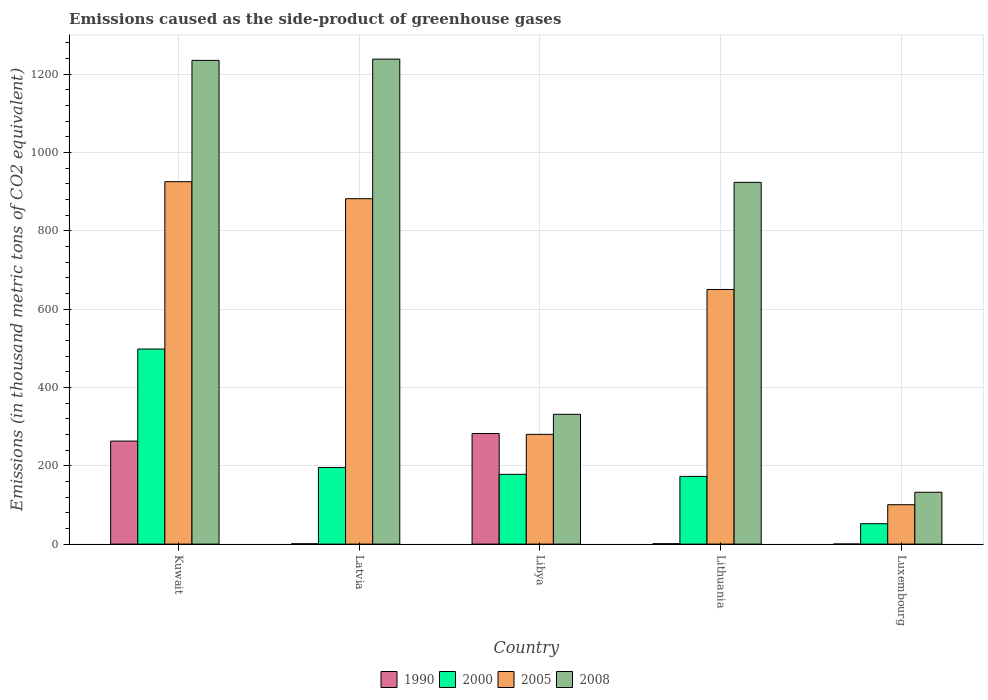How many groups of bars are there?
Give a very brief answer. 5. Are the number of bars on each tick of the X-axis equal?
Keep it short and to the point. Yes. How many bars are there on the 3rd tick from the left?
Keep it short and to the point. 4. What is the label of the 5th group of bars from the left?
Your response must be concise. Luxembourg. What is the emissions caused as the side-product of greenhouse gases in 2005 in Latvia?
Offer a terse response. 882.1. Across all countries, what is the maximum emissions caused as the side-product of greenhouse gases in 2008?
Ensure brevity in your answer.  1238.6. Across all countries, what is the minimum emissions caused as the side-product of greenhouse gases in 2000?
Make the answer very short. 52.1. In which country was the emissions caused as the side-product of greenhouse gases in 2008 maximum?
Ensure brevity in your answer.  Latvia. In which country was the emissions caused as the side-product of greenhouse gases in 1990 minimum?
Ensure brevity in your answer.  Luxembourg. What is the total emissions caused as the side-product of greenhouse gases in 2005 in the graph?
Offer a terse response. 2838.9. What is the difference between the emissions caused as the side-product of greenhouse gases in 2008 in Libya and that in Luxembourg?
Offer a terse response. 199.1. What is the difference between the emissions caused as the side-product of greenhouse gases in 2000 in Lithuania and the emissions caused as the side-product of greenhouse gases in 1990 in Latvia?
Your response must be concise. 172.1. What is the average emissions caused as the side-product of greenhouse gases in 2008 per country?
Provide a succinct answer. 772.36. What is the difference between the emissions caused as the side-product of greenhouse gases of/in 1990 and emissions caused as the side-product of greenhouse gases of/in 2008 in Libya?
Your response must be concise. -49.1. In how many countries, is the emissions caused as the side-product of greenhouse gases in 2000 greater than 720 thousand metric tons?
Provide a short and direct response. 0. What is the ratio of the emissions caused as the side-product of greenhouse gases in 2000 in Libya to that in Luxembourg?
Your answer should be compact. 3.42. What is the difference between the highest and the second highest emissions caused as the side-product of greenhouse gases in 2005?
Keep it short and to the point. -43.5. What is the difference between the highest and the lowest emissions caused as the side-product of greenhouse gases in 2005?
Ensure brevity in your answer.  825. In how many countries, is the emissions caused as the side-product of greenhouse gases in 2000 greater than the average emissions caused as the side-product of greenhouse gases in 2000 taken over all countries?
Provide a short and direct response. 1. Is the sum of the emissions caused as the side-product of greenhouse gases in 2000 in Kuwait and Lithuania greater than the maximum emissions caused as the side-product of greenhouse gases in 2008 across all countries?
Offer a terse response. No. Is it the case that in every country, the sum of the emissions caused as the side-product of greenhouse gases in 1990 and emissions caused as the side-product of greenhouse gases in 2005 is greater than the sum of emissions caused as the side-product of greenhouse gases in 2008 and emissions caused as the side-product of greenhouse gases in 2000?
Your response must be concise. No. Is it the case that in every country, the sum of the emissions caused as the side-product of greenhouse gases in 2000 and emissions caused as the side-product of greenhouse gases in 2008 is greater than the emissions caused as the side-product of greenhouse gases in 1990?
Ensure brevity in your answer.  Yes. How many bars are there?
Your answer should be very brief. 20. What is the difference between two consecutive major ticks on the Y-axis?
Your answer should be compact. 200. Are the values on the major ticks of Y-axis written in scientific E-notation?
Provide a succinct answer. No. Does the graph contain grids?
Ensure brevity in your answer.  Yes. Where does the legend appear in the graph?
Provide a succinct answer. Bottom center. How many legend labels are there?
Keep it short and to the point. 4. How are the legend labels stacked?
Give a very brief answer. Horizontal. What is the title of the graph?
Your response must be concise. Emissions caused as the side-product of greenhouse gases. What is the label or title of the X-axis?
Your answer should be compact. Country. What is the label or title of the Y-axis?
Give a very brief answer. Emissions (in thousand metric tons of CO2 equivalent). What is the Emissions (in thousand metric tons of CO2 equivalent) in 1990 in Kuwait?
Keep it short and to the point. 263.1. What is the Emissions (in thousand metric tons of CO2 equivalent) in 2000 in Kuwait?
Provide a short and direct response. 498.2. What is the Emissions (in thousand metric tons of CO2 equivalent) in 2005 in Kuwait?
Provide a short and direct response. 925.6. What is the Emissions (in thousand metric tons of CO2 equivalent) in 2008 in Kuwait?
Make the answer very short. 1235.4. What is the Emissions (in thousand metric tons of CO2 equivalent) of 1990 in Latvia?
Ensure brevity in your answer.  0.8. What is the Emissions (in thousand metric tons of CO2 equivalent) in 2000 in Latvia?
Your answer should be compact. 195.7. What is the Emissions (in thousand metric tons of CO2 equivalent) of 2005 in Latvia?
Offer a very short reply. 882.1. What is the Emissions (in thousand metric tons of CO2 equivalent) in 2008 in Latvia?
Offer a very short reply. 1238.6. What is the Emissions (in thousand metric tons of CO2 equivalent) in 1990 in Libya?
Keep it short and to the point. 282.4. What is the Emissions (in thousand metric tons of CO2 equivalent) of 2000 in Libya?
Your answer should be compact. 178.2. What is the Emissions (in thousand metric tons of CO2 equivalent) in 2005 in Libya?
Provide a succinct answer. 280.3. What is the Emissions (in thousand metric tons of CO2 equivalent) of 2008 in Libya?
Ensure brevity in your answer.  331.5. What is the Emissions (in thousand metric tons of CO2 equivalent) in 1990 in Lithuania?
Offer a very short reply. 1. What is the Emissions (in thousand metric tons of CO2 equivalent) of 2000 in Lithuania?
Offer a terse response. 172.9. What is the Emissions (in thousand metric tons of CO2 equivalent) of 2005 in Lithuania?
Provide a short and direct response. 650.3. What is the Emissions (in thousand metric tons of CO2 equivalent) in 2008 in Lithuania?
Your answer should be compact. 923.9. What is the Emissions (in thousand metric tons of CO2 equivalent) in 2000 in Luxembourg?
Keep it short and to the point. 52.1. What is the Emissions (in thousand metric tons of CO2 equivalent) in 2005 in Luxembourg?
Keep it short and to the point. 100.6. What is the Emissions (in thousand metric tons of CO2 equivalent) of 2008 in Luxembourg?
Your answer should be very brief. 132.4. Across all countries, what is the maximum Emissions (in thousand metric tons of CO2 equivalent) of 1990?
Offer a terse response. 282.4. Across all countries, what is the maximum Emissions (in thousand metric tons of CO2 equivalent) in 2000?
Offer a terse response. 498.2. Across all countries, what is the maximum Emissions (in thousand metric tons of CO2 equivalent) in 2005?
Give a very brief answer. 925.6. Across all countries, what is the maximum Emissions (in thousand metric tons of CO2 equivalent) of 2008?
Keep it short and to the point. 1238.6. Across all countries, what is the minimum Emissions (in thousand metric tons of CO2 equivalent) of 1990?
Provide a short and direct response. 0.2. Across all countries, what is the minimum Emissions (in thousand metric tons of CO2 equivalent) of 2000?
Provide a succinct answer. 52.1. Across all countries, what is the minimum Emissions (in thousand metric tons of CO2 equivalent) of 2005?
Your answer should be compact. 100.6. Across all countries, what is the minimum Emissions (in thousand metric tons of CO2 equivalent) of 2008?
Your response must be concise. 132.4. What is the total Emissions (in thousand metric tons of CO2 equivalent) in 1990 in the graph?
Your response must be concise. 547.5. What is the total Emissions (in thousand metric tons of CO2 equivalent) of 2000 in the graph?
Provide a short and direct response. 1097.1. What is the total Emissions (in thousand metric tons of CO2 equivalent) in 2005 in the graph?
Offer a terse response. 2838.9. What is the total Emissions (in thousand metric tons of CO2 equivalent) of 2008 in the graph?
Provide a succinct answer. 3861.8. What is the difference between the Emissions (in thousand metric tons of CO2 equivalent) in 1990 in Kuwait and that in Latvia?
Offer a terse response. 262.3. What is the difference between the Emissions (in thousand metric tons of CO2 equivalent) in 2000 in Kuwait and that in Latvia?
Give a very brief answer. 302.5. What is the difference between the Emissions (in thousand metric tons of CO2 equivalent) of 2005 in Kuwait and that in Latvia?
Provide a short and direct response. 43.5. What is the difference between the Emissions (in thousand metric tons of CO2 equivalent) of 1990 in Kuwait and that in Libya?
Your answer should be compact. -19.3. What is the difference between the Emissions (in thousand metric tons of CO2 equivalent) of 2000 in Kuwait and that in Libya?
Provide a short and direct response. 320. What is the difference between the Emissions (in thousand metric tons of CO2 equivalent) in 2005 in Kuwait and that in Libya?
Give a very brief answer. 645.3. What is the difference between the Emissions (in thousand metric tons of CO2 equivalent) of 2008 in Kuwait and that in Libya?
Give a very brief answer. 903.9. What is the difference between the Emissions (in thousand metric tons of CO2 equivalent) of 1990 in Kuwait and that in Lithuania?
Your answer should be compact. 262.1. What is the difference between the Emissions (in thousand metric tons of CO2 equivalent) in 2000 in Kuwait and that in Lithuania?
Give a very brief answer. 325.3. What is the difference between the Emissions (in thousand metric tons of CO2 equivalent) in 2005 in Kuwait and that in Lithuania?
Provide a short and direct response. 275.3. What is the difference between the Emissions (in thousand metric tons of CO2 equivalent) in 2008 in Kuwait and that in Lithuania?
Your answer should be very brief. 311.5. What is the difference between the Emissions (in thousand metric tons of CO2 equivalent) in 1990 in Kuwait and that in Luxembourg?
Your answer should be very brief. 262.9. What is the difference between the Emissions (in thousand metric tons of CO2 equivalent) of 2000 in Kuwait and that in Luxembourg?
Offer a very short reply. 446.1. What is the difference between the Emissions (in thousand metric tons of CO2 equivalent) in 2005 in Kuwait and that in Luxembourg?
Make the answer very short. 825. What is the difference between the Emissions (in thousand metric tons of CO2 equivalent) in 2008 in Kuwait and that in Luxembourg?
Your answer should be compact. 1103. What is the difference between the Emissions (in thousand metric tons of CO2 equivalent) of 1990 in Latvia and that in Libya?
Your answer should be compact. -281.6. What is the difference between the Emissions (in thousand metric tons of CO2 equivalent) in 2005 in Latvia and that in Libya?
Ensure brevity in your answer.  601.8. What is the difference between the Emissions (in thousand metric tons of CO2 equivalent) of 2008 in Latvia and that in Libya?
Ensure brevity in your answer.  907.1. What is the difference between the Emissions (in thousand metric tons of CO2 equivalent) of 2000 in Latvia and that in Lithuania?
Make the answer very short. 22.8. What is the difference between the Emissions (in thousand metric tons of CO2 equivalent) in 2005 in Latvia and that in Lithuania?
Offer a terse response. 231.8. What is the difference between the Emissions (in thousand metric tons of CO2 equivalent) in 2008 in Latvia and that in Lithuania?
Provide a succinct answer. 314.7. What is the difference between the Emissions (in thousand metric tons of CO2 equivalent) of 2000 in Latvia and that in Luxembourg?
Your response must be concise. 143.6. What is the difference between the Emissions (in thousand metric tons of CO2 equivalent) in 2005 in Latvia and that in Luxembourg?
Offer a terse response. 781.5. What is the difference between the Emissions (in thousand metric tons of CO2 equivalent) in 2008 in Latvia and that in Luxembourg?
Offer a very short reply. 1106.2. What is the difference between the Emissions (in thousand metric tons of CO2 equivalent) in 1990 in Libya and that in Lithuania?
Provide a succinct answer. 281.4. What is the difference between the Emissions (in thousand metric tons of CO2 equivalent) of 2000 in Libya and that in Lithuania?
Ensure brevity in your answer.  5.3. What is the difference between the Emissions (in thousand metric tons of CO2 equivalent) of 2005 in Libya and that in Lithuania?
Offer a terse response. -370. What is the difference between the Emissions (in thousand metric tons of CO2 equivalent) of 2008 in Libya and that in Lithuania?
Provide a short and direct response. -592.4. What is the difference between the Emissions (in thousand metric tons of CO2 equivalent) in 1990 in Libya and that in Luxembourg?
Ensure brevity in your answer.  282.2. What is the difference between the Emissions (in thousand metric tons of CO2 equivalent) of 2000 in Libya and that in Luxembourg?
Give a very brief answer. 126.1. What is the difference between the Emissions (in thousand metric tons of CO2 equivalent) of 2005 in Libya and that in Luxembourg?
Provide a short and direct response. 179.7. What is the difference between the Emissions (in thousand metric tons of CO2 equivalent) of 2008 in Libya and that in Luxembourg?
Keep it short and to the point. 199.1. What is the difference between the Emissions (in thousand metric tons of CO2 equivalent) of 2000 in Lithuania and that in Luxembourg?
Your response must be concise. 120.8. What is the difference between the Emissions (in thousand metric tons of CO2 equivalent) in 2005 in Lithuania and that in Luxembourg?
Ensure brevity in your answer.  549.7. What is the difference between the Emissions (in thousand metric tons of CO2 equivalent) of 2008 in Lithuania and that in Luxembourg?
Provide a succinct answer. 791.5. What is the difference between the Emissions (in thousand metric tons of CO2 equivalent) in 1990 in Kuwait and the Emissions (in thousand metric tons of CO2 equivalent) in 2000 in Latvia?
Offer a very short reply. 67.4. What is the difference between the Emissions (in thousand metric tons of CO2 equivalent) in 1990 in Kuwait and the Emissions (in thousand metric tons of CO2 equivalent) in 2005 in Latvia?
Your response must be concise. -619. What is the difference between the Emissions (in thousand metric tons of CO2 equivalent) of 1990 in Kuwait and the Emissions (in thousand metric tons of CO2 equivalent) of 2008 in Latvia?
Your answer should be compact. -975.5. What is the difference between the Emissions (in thousand metric tons of CO2 equivalent) in 2000 in Kuwait and the Emissions (in thousand metric tons of CO2 equivalent) in 2005 in Latvia?
Give a very brief answer. -383.9. What is the difference between the Emissions (in thousand metric tons of CO2 equivalent) in 2000 in Kuwait and the Emissions (in thousand metric tons of CO2 equivalent) in 2008 in Latvia?
Offer a very short reply. -740.4. What is the difference between the Emissions (in thousand metric tons of CO2 equivalent) of 2005 in Kuwait and the Emissions (in thousand metric tons of CO2 equivalent) of 2008 in Latvia?
Ensure brevity in your answer.  -313. What is the difference between the Emissions (in thousand metric tons of CO2 equivalent) of 1990 in Kuwait and the Emissions (in thousand metric tons of CO2 equivalent) of 2000 in Libya?
Your answer should be very brief. 84.9. What is the difference between the Emissions (in thousand metric tons of CO2 equivalent) in 1990 in Kuwait and the Emissions (in thousand metric tons of CO2 equivalent) in 2005 in Libya?
Your answer should be very brief. -17.2. What is the difference between the Emissions (in thousand metric tons of CO2 equivalent) in 1990 in Kuwait and the Emissions (in thousand metric tons of CO2 equivalent) in 2008 in Libya?
Give a very brief answer. -68.4. What is the difference between the Emissions (in thousand metric tons of CO2 equivalent) in 2000 in Kuwait and the Emissions (in thousand metric tons of CO2 equivalent) in 2005 in Libya?
Offer a very short reply. 217.9. What is the difference between the Emissions (in thousand metric tons of CO2 equivalent) in 2000 in Kuwait and the Emissions (in thousand metric tons of CO2 equivalent) in 2008 in Libya?
Make the answer very short. 166.7. What is the difference between the Emissions (in thousand metric tons of CO2 equivalent) in 2005 in Kuwait and the Emissions (in thousand metric tons of CO2 equivalent) in 2008 in Libya?
Your answer should be very brief. 594.1. What is the difference between the Emissions (in thousand metric tons of CO2 equivalent) in 1990 in Kuwait and the Emissions (in thousand metric tons of CO2 equivalent) in 2000 in Lithuania?
Your response must be concise. 90.2. What is the difference between the Emissions (in thousand metric tons of CO2 equivalent) in 1990 in Kuwait and the Emissions (in thousand metric tons of CO2 equivalent) in 2005 in Lithuania?
Your response must be concise. -387.2. What is the difference between the Emissions (in thousand metric tons of CO2 equivalent) in 1990 in Kuwait and the Emissions (in thousand metric tons of CO2 equivalent) in 2008 in Lithuania?
Keep it short and to the point. -660.8. What is the difference between the Emissions (in thousand metric tons of CO2 equivalent) of 2000 in Kuwait and the Emissions (in thousand metric tons of CO2 equivalent) of 2005 in Lithuania?
Your answer should be very brief. -152.1. What is the difference between the Emissions (in thousand metric tons of CO2 equivalent) in 2000 in Kuwait and the Emissions (in thousand metric tons of CO2 equivalent) in 2008 in Lithuania?
Your response must be concise. -425.7. What is the difference between the Emissions (in thousand metric tons of CO2 equivalent) in 2005 in Kuwait and the Emissions (in thousand metric tons of CO2 equivalent) in 2008 in Lithuania?
Give a very brief answer. 1.7. What is the difference between the Emissions (in thousand metric tons of CO2 equivalent) of 1990 in Kuwait and the Emissions (in thousand metric tons of CO2 equivalent) of 2000 in Luxembourg?
Keep it short and to the point. 211. What is the difference between the Emissions (in thousand metric tons of CO2 equivalent) in 1990 in Kuwait and the Emissions (in thousand metric tons of CO2 equivalent) in 2005 in Luxembourg?
Your response must be concise. 162.5. What is the difference between the Emissions (in thousand metric tons of CO2 equivalent) in 1990 in Kuwait and the Emissions (in thousand metric tons of CO2 equivalent) in 2008 in Luxembourg?
Your answer should be very brief. 130.7. What is the difference between the Emissions (in thousand metric tons of CO2 equivalent) in 2000 in Kuwait and the Emissions (in thousand metric tons of CO2 equivalent) in 2005 in Luxembourg?
Keep it short and to the point. 397.6. What is the difference between the Emissions (in thousand metric tons of CO2 equivalent) of 2000 in Kuwait and the Emissions (in thousand metric tons of CO2 equivalent) of 2008 in Luxembourg?
Provide a short and direct response. 365.8. What is the difference between the Emissions (in thousand metric tons of CO2 equivalent) of 2005 in Kuwait and the Emissions (in thousand metric tons of CO2 equivalent) of 2008 in Luxembourg?
Make the answer very short. 793.2. What is the difference between the Emissions (in thousand metric tons of CO2 equivalent) in 1990 in Latvia and the Emissions (in thousand metric tons of CO2 equivalent) in 2000 in Libya?
Give a very brief answer. -177.4. What is the difference between the Emissions (in thousand metric tons of CO2 equivalent) in 1990 in Latvia and the Emissions (in thousand metric tons of CO2 equivalent) in 2005 in Libya?
Your response must be concise. -279.5. What is the difference between the Emissions (in thousand metric tons of CO2 equivalent) in 1990 in Latvia and the Emissions (in thousand metric tons of CO2 equivalent) in 2008 in Libya?
Give a very brief answer. -330.7. What is the difference between the Emissions (in thousand metric tons of CO2 equivalent) of 2000 in Latvia and the Emissions (in thousand metric tons of CO2 equivalent) of 2005 in Libya?
Offer a terse response. -84.6. What is the difference between the Emissions (in thousand metric tons of CO2 equivalent) in 2000 in Latvia and the Emissions (in thousand metric tons of CO2 equivalent) in 2008 in Libya?
Make the answer very short. -135.8. What is the difference between the Emissions (in thousand metric tons of CO2 equivalent) of 2005 in Latvia and the Emissions (in thousand metric tons of CO2 equivalent) of 2008 in Libya?
Your answer should be compact. 550.6. What is the difference between the Emissions (in thousand metric tons of CO2 equivalent) of 1990 in Latvia and the Emissions (in thousand metric tons of CO2 equivalent) of 2000 in Lithuania?
Offer a very short reply. -172.1. What is the difference between the Emissions (in thousand metric tons of CO2 equivalent) of 1990 in Latvia and the Emissions (in thousand metric tons of CO2 equivalent) of 2005 in Lithuania?
Offer a very short reply. -649.5. What is the difference between the Emissions (in thousand metric tons of CO2 equivalent) of 1990 in Latvia and the Emissions (in thousand metric tons of CO2 equivalent) of 2008 in Lithuania?
Your answer should be compact. -923.1. What is the difference between the Emissions (in thousand metric tons of CO2 equivalent) in 2000 in Latvia and the Emissions (in thousand metric tons of CO2 equivalent) in 2005 in Lithuania?
Make the answer very short. -454.6. What is the difference between the Emissions (in thousand metric tons of CO2 equivalent) of 2000 in Latvia and the Emissions (in thousand metric tons of CO2 equivalent) of 2008 in Lithuania?
Provide a short and direct response. -728.2. What is the difference between the Emissions (in thousand metric tons of CO2 equivalent) of 2005 in Latvia and the Emissions (in thousand metric tons of CO2 equivalent) of 2008 in Lithuania?
Offer a very short reply. -41.8. What is the difference between the Emissions (in thousand metric tons of CO2 equivalent) of 1990 in Latvia and the Emissions (in thousand metric tons of CO2 equivalent) of 2000 in Luxembourg?
Offer a very short reply. -51.3. What is the difference between the Emissions (in thousand metric tons of CO2 equivalent) of 1990 in Latvia and the Emissions (in thousand metric tons of CO2 equivalent) of 2005 in Luxembourg?
Provide a succinct answer. -99.8. What is the difference between the Emissions (in thousand metric tons of CO2 equivalent) in 1990 in Latvia and the Emissions (in thousand metric tons of CO2 equivalent) in 2008 in Luxembourg?
Keep it short and to the point. -131.6. What is the difference between the Emissions (in thousand metric tons of CO2 equivalent) in 2000 in Latvia and the Emissions (in thousand metric tons of CO2 equivalent) in 2005 in Luxembourg?
Provide a succinct answer. 95.1. What is the difference between the Emissions (in thousand metric tons of CO2 equivalent) of 2000 in Latvia and the Emissions (in thousand metric tons of CO2 equivalent) of 2008 in Luxembourg?
Provide a succinct answer. 63.3. What is the difference between the Emissions (in thousand metric tons of CO2 equivalent) of 2005 in Latvia and the Emissions (in thousand metric tons of CO2 equivalent) of 2008 in Luxembourg?
Provide a short and direct response. 749.7. What is the difference between the Emissions (in thousand metric tons of CO2 equivalent) in 1990 in Libya and the Emissions (in thousand metric tons of CO2 equivalent) in 2000 in Lithuania?
Offer a very short reply. 109.5. What is the difference between the Emissions (in thousand metric tons of CO2 equivalent) of 1990 in Libya and the Emissions (in thousand metric tons of CO2 equivalent) of 2005 in Lithuania?
Offer a terse response. -367.9. What is the difference between the Emissions (in thousand metric tons of CO2 equivalent) of 1990 in Libya and the Emissions (in thousand metric tons of CO2 equivalent) of 2008 in Lithuania?
Your answer should be very brief. -641.5. What is the difference between the Emissions (in thousand metric tons of CO2 equivalent) of 2000 in Libya and the Emissions (in thousand metric tons of CO2 equivalent) of 2005 in Lithuania?
Offer a terse response. -472.1. What is the difference between the Emissions (in thousand metric tons of CO2 equivalent) of 2000 in Libya and the Emissions (in thousand metric tons of CO2 equivalent) of 2008 in Lithuania?
Your answer should be very brief. -745.7. What is the difference between the Emissions (in thousand metric tons of CO2 equivalent) of 2005 in Libya and the Emissions (in thousand metric tons of CO2 equivalent) of 2008 in Lithuania?
Provide a short and direct response. -643.6. What is the difference between the Emissions (in thousand metric tons of CO2 equivalent) in 1990 in Libya and the Emissions (in thousand metric tons of CO2 equivalent) in 2000 in Luxembourg?
Your answer should be compact. 230.3. What is the difference between the Emissions (in thousand metric tons of CO2 equivalent) of 1990 in Libya and the Emissions (in thousand metric tons of CO2 equivalent) of 2005 in Luxembourg?
Give a very brief answer. 181.8. What is the difference between the Emissions (in thousand metric tons of CO2 equivalent) in 1990 in Libya and the Emissions (in thousand metric tons of CO2 equivalent) in 2008 in Luxembourg?
Your answer should be compact. 150. What is the difference between the Emissions (in thousand metric tons of CO2 equivalent) of 2000 in Libya and the Emissions (in thousand metric tons of CO2 equivalent) of 2005 in Luxembourg?
Offer a very short reply. 77.6. What is the difference between the Emissions (in thousand metric tons of CO2 equivalent) of 2000 in Libya and the Emissions (in thousand metric tons of CO2 equivalent) of 2008 in Luxembourg?
Your response must be concise. 45.8. What is the difference between the Emissions (in thousand metric tons of CO2 equivalent) in 2005 in Libya and the Emissions (in thousand metric tons of CO2 equivalent) in 2008 in Luxembourg?
Your answer should be compact. 147.9. What is the difference between the Emissions (in thousand metric tons of CO2 equivalent) of 1990 in Lithuania and the Emissions (in thousand metric tons of CO2 equivalent) of 2000 in Luxembourg?
Ensure brevity in your answer.  -51.1. What is the difference between the Emissions (in thousand metric tons of CO2 equivalent) in 1990 in Lithuania and the Emissions (in thousand metric tons of CO2 equivalent) in 2005 in Luxembourg?
Your response must be concise. -99.6. What is the difference between the Emissions (in thousand metric tons of CO2 equivalent) in 1990 in Lithuania and the Emissions (in thousand metric tons of CO2 equivalent) in 2008 in Luxembourg?
Keep it short and to the point. -131.4. What is the difference between the Emissions (in thousand metric tons of CO2 equivalent) in 2000 in Lithuania and the Emissions (in thousand metric tons of CO2 equivalent) in 2005 in Luxembourg?
Offer a very short reply. 72.3. What is the difference between the Emissions (in thousand metric tons of CO2 equivalent) of 2000 in Lithuania and the Emissions (in thousand metric tons of CO2 equivalent) of 2008 in Luxembourg?
Offer a terse response. 40.5. What is the difference between the Emissions (in thousand metric tons of CO2 equivalent) in 2005 in Lithuania and the Emissions (in thousand metric tons of CO2 equivalent) in 2008 in Luxembourg?
Give a very brief answer. 517.9. What is the average Emissions (in thousand metric tons of CO2 equivalent) in 1990 per country?
Give a very brief answer. 109.5. What is the average Emissions (in thousand metric tons of CO2 equivalent) in 2000 per country?
Your answer should be very brief. 219.42. What is the average Emissions (in thousand metric tons of CO2 equivalent) of 2005 per country?
Ensure brevity in your answer.  567.78. What is the average Emissions (in thousand metric tons of CO2 equivalent) in 2008 per country?
Give a very brief answer. 772.36. What is the difference between the Emissions (in thousand metric tons of CO2 equivalent) of 1990 and Emissions (in thousand metric tons of CO2 equivalent) of 2000 in Kuwait?
Offer a terse response. -235.1. What is the difference between the Emissions (in thousand metric tons of CO2 equivalent) in 1990 and Emissions (in thousand metric tons of CO2 equivalent) in 2005 in Kuwait?
Offer a very short reply. -662.5. What is the difference between the Emissions (in thousand metric tons of CO2 equivalent) of 1990 and Emissions (in thousand metric tons of CO2 equivalent) of 2008 in Kuwait?
Ensure brevity in your answer.  -972.3. What is the difference between the Emissions (in thousand metric tons of CO2 equivalent) of 2000 and Emissions (in thousand metric tons of CO2 equivalent) of 2005 in Kuwait?
Your answer should be very brief. -427.4. What is the difference between the Emissions (in thousand metric tons of CO2 equivalent) in 2000 and Emissions (in thousand metric tons of CO2 equivalent) in 2008 in Kuwait?
Give a very brief answer. -737.2. What is the difference between the Emissions (in thousand metric tons of CO2 equivalent) in 2005 and Emissions (in thousand metric tons of CO2 equivalent) in 2008 in Kuwait?
Offer a terse response. -309.8. What is the difference between the Emissions (in thousand metric tons of CO2 equivalent) in 1990 and Emissions (in thousand metric tons of CO2 equivalent) in 2000 in Latvia?
Provide a succinct answer. -194.9. What is the difference between the Emissions (in thousand metric tons of CO2 equivalent) in 1990 and Emissions (in thousand metric tons of CO2 equivalent) in 2005 in Latvia?
Give a very brief answer. -881.3. What is the difference between the Emissions (in thousand metric tons of CO2 equivalent) in 1990 and Emissions (in thousand metric tons of CO2 equivalent) in 2008 in Latvia?
Keep it short and to the point. -1237.8. What is the difference between the Emissions (in thousand metric tons of CO2 equivalent) of 2000 and Emissions (in thousand metric tons of CO2 equivalent) of 2005 in Latvia?
Keep it short and to the point. -686.4. What is the difference between the Emissions (in thousand metric tons of CO2 equivalent) in 2000 and Emissions (in thousand metric tons of CO2 equivalent) in 2008 in Latvia?
Offer a terse response. -1042.9. What is the difference between the Emissions (in thousand metric tons of CO2 equivalent) in 2005 and Emissions (in thousand metric tons of CO2 equivalent) in 2008 in Latvia?
Offer a terse response. -356.5. What is the difference between the Emissions (in thousand metric tons of CO2 equivalent) of 1990 and Emissions (in thousand metric tons of CO2 equivalent) of 2000 in Libya?
Provide a short and direct response. 104.2. What is the difference between the Emissions (in thousand metric tons of CO2 equivalent) in 1990 and Emissions (in thousand metric tons of CO2 equivalent) in 2005 in Libya?
Offer a very short reply. 2.1. What is the difference between the Emissions (in thousand metric tons of CO2 equivalent) in 1990 and Emissions (in thousand metric tons of CO2 equivalent) in 2008 in Libya?
Offer a terse response. -49.1. What is the difference between the Emissions (in thousand metric tons of CO2 equivalent) in 2000 and Emissions (in thousand metric tons of CO2 equivalent) in 2005 in Libya?
Your response must be concise. -102.1. What is the difference between the Emissions (in thousand metric tons of CO2 equivalent) of 2000 and Emissions (in thousand metric tons of CO2 equivalent) of 2008 in Libya?
Offer a terse response. -153.3. What is the difference between the Emissions (in thousand metric tons of CO2 equivalent) in 2005 and Emissions (in thousand metric tons of CO2 equivalent) in 2008 in Libya?
Provide a short and direct response. -51.2. What is the difference between the Emissions (in thousand metric tons of CO2 equivalent) of 1990 and Emissions (in thousand metric tons of CO2 equivalent) of 2000 in Lithuania?
Provide a short and direct response. -171.9. What is the difference between the Emissions (in thousand metric tons of CO2 equivalent) in 1990 and Emissions (in thousand metric tons of CO2 equivalent) in 2005 in Lithuania?
Offer a terse response. -649.3. What is the difference between the Emissions (in thousand metric tons of CO2 equivalent) in 1990 and Emissions (in thousand metric tons of CO2 equivalent) in 2008 in Lithuania?
Ensure brevity in your answer.  -922.9. What is the difference between the Emissions (in thousand metric tons of CO2 equivalent) in 2000 and Emissions (in thousand metric tons of CO2 equivalent) in 2005 in Lithuania?
Offer a very short reply. -477.4. What is the difference between the Emissions (in thousand metric tons of CO2 equivalent) in 2000 and Emissions (in thousand metric tons of CO2 equivalent) in 2008 in Lithuania?
Provide a succinct answer. -751. What is the difference between the Emissions (in thousand metric tons of CO2 equivalent) of 2005 and Emissions (in thousand metric tons of CO2 equivalent) of 2008 in Lithuania?
Provide a succinct answer. -273.6. What is the difference between the Emissions (in thousand metric tons of CO2 equivalent) in 1990 and Emissions (in thousand metric tons of CO2 equivalent) in 2000 in Luxembourg?
Make the answer very short. -51.9. What is the difference between the Emissions (in thousand metric tons of CO2 equivalent) in 1990 and Emissions (in thousand metric tons of CO2 equivalent) in 2005 in Luxembourg?
Your response must be concise. -100.4. What is the difference between the Emissions (in thousand metric tons of CO2 equivalent) in 1990 and Emissions (in thousand metric tons of CO2 equivalent) in 2008 in Luxembourg?
Offer a very short reply. -132.2. What is the difference between the Emissions (in thousand metric tons of CO2 equivalent) in 2000 and Emissions (in thousand metric tons of CO2 equivalent) in 2005 in Luxembourg?
Keep it short and to the point. -48.5. What is the difference between the Emissions (in thousand metric tons of CO2 equivalent) in 2000 and Emissions (in thousand metric tons of CO2 equivalent) in 2008 in Luxembourg?
Give a very brief answer. -80.3. What is the difference between the Emissions (in thousand metric tons of CO2 equivalent) in 2005 and Emissions (in thousand metric tons of CO2 equivalent) in 2008 in Luxembourg?
Offer a very short reply. -31.8. What is the ratio of the Emissions (in thousand metric tons of CO2 equivalent) in 1990 in Kuwait to that in Latvia?
Your response must be concise. 328.88. What is the ratio of the Emissions (in thousand metric tons of CO2 equivalent) of 2000 in Kuwait to that in Latvia?
Your response must be concise. 2.55. What is the ratio of the Emissions (in thousand metric tons of CO2 equivalent) in 2005 in Kuwait to that in Latvia?
Provide a succinct answer. 1.05. What is the ratio of the Emissions (in thousand metric tons of CO2 equivalent) of 1990 in Kuwait to that in Libya?
Ensure brevity in your answer.  0.93. What is the ratio of the Emissions (in thousand metric tons of CO2 equivalent) in 2000 in Kuwait to that in Libya?
Offer a terse response. 2.8. What is the ratio of the Emissions (in thousand metric tons of CO2 equivalent) of 2005 in Kuwait to that in Libya?
Offer a terse response. 3.3. What is the ratio of the Emissions (in thousand metric tons of CO2 equivalent) in 2008 in Kuwait to that in Libya?
Ensure brevity in your answer.  3.73. What is the ratio of the Emissions (in thousand metric tons of CO2 equivalent) in 1990 in Kuwait to that in Lithuania?
Keep it short and to the point. 263.1. What is the ratio of the Emissions (in thousand metric tons of CO2 equivalent) of 2000 in Kuwait to that in Lithuania?
Your response must be concise. 2.88. What is the ratio of the Emissions (in thousand metric tons of CO2 equivalent) in 2005 in Kuwait to that in Lithuania?
Provide a short and direct response. 1.42. What is the ratio of the Emissions (in thousand metric tons of CO2 equivalent) in 2008 in Kuwait to that in Lithuania?
Your answer should be compact. 1.34. What is the ratio of the Emissions (in thousand metric tons of CO2 equivalent) in 1990 in Kuwait to that in Luxembourg?
Ensure brevity in your answer.  1315.5. What is the ratio of the Emissions (in thousand metric tons of CO2 equivalent) in 2000 in Kuwait to that in Luxembourg?
Keep it short and to the point. 9.56. What is the ratio of the Emissions (in thousand metric tons of CO2 equivalent) in 2005 in Kuwait to that in Luxembourg?
Give a very brief answer. 9.2. What is the ratio of the Emissions (in thousand metric tons of CO2 equivalent) in 2008 in Kuwait to that in Luxembourg?
Provide a short and direct response. 9.33. What is the ratio of the Emissions (in thousand metric tons of CO2 equivalent) of 1990 in Latvia to that in Libya?
Your answer should be very brief. 0. What is the ratio of the Emissions (in thousand metric tons of CO2 equivalent) of 2000 in Latvia to that in Libya?
Give a very brief answer. 1.1. What is the ratio of the Emissions (in thousand metric tons of CO2 equivalent) of 2005 in Latvia to that in Libya?
Your answer should be very brief. 3.15. What is the ratio of the Emissions (in thousand metric tons of CO2 equivalent) in 2008 in Latvia to that in Libya?
Ensure brevity in your answer.  3.74. What is the ratio of the Emissions (in thousand metric tons of CO2 equivalent) in 2000 in Latvia to that in Lithuania?
Offer a very short reply. 1.13. What is the ratio of the Emissions (in thousand metric tons of CO2 equivalent) in 2005 in Latvia to that in Lithuania?
Your answer should be very brief. 1.36. What is the ratio of the Emissions (in thousand metric tons of CO2 equivalent) of 2008 in Latvia to that in Lithuania?
Offer a terse response. 1.34. What is the ratio of the Emissions (in thousand metric tons of CO2 equivalent) in 2000 in Latvia to that in Luxembourg?
Offer a terse response. 3.76. What is the ratio of the Emissions (in thousand metric tons of CO2 equivalent) in 2005 in Latvia to that in Luxembourg?
Keep it short and to the point. 8.77. What is the ratio of the Emissions (in thousand metric tons of CO2 equivalent) in 2008 in Latvia to that in Luxembourg?
Offer a terse response. 9.36. What is the ratio of the Emissions (in thousand metric tons of CO2 equivalent) of 1990 in Libya to that in Lithuania?
Offer a terse response. 282.4. What is the ratio of the Emissions (in thousand metric tons of CO2 equivalent) in 2000 in Libya to that in Lithuania?
Provide a short and direct response. 1.03. What is the ratio of the Emissions (in thousand metric tons of CO2 equivalent) of 2005 in Libya to that in Lithuania?
Make the answer very short. 0.43. What is the ratio of the Emissions (in thousand metric tons of CO2 equivalent) in 2008 in Libya to that in Lithuania?
Your response must be concise. 0.36. What is the ratio of the Emissions (in thousand metric tons of CO2 equivalent) of 1990 in Libya to that in Luxembourg?
Your answer should be very brief. 1412. What is the ratio of the Emissions (in thousand metric tons of CO2 equivalent) of 2000 in Libya to that in Luxembourg?
Keep it short and to the point. 3.42. What is the ratio of the Emissions (in thousand metric tons of CO2 equivalent) of 2005 in Libya to that in Luxembourg?
Make the answer very short. 2.79. What is the ratio of the Emissions (in thousand metric tons of CO2 equivalent) of 2008 in Libya to that in Luxembourg?
Keep it short and to the point. 2.5. What is the ratio of the Emissions (in thousand metric tons of CO2 equivalent) in 2000 in Lithuania to that in Luxembourg?
Your answer should be very brief. 3.32. What is the ratio of the Emissions (in thousand metric tons of CO2 equivalent) in 2005 in Lithuania to that in Luxembourg?
Your answer should be very brief. 6.46. What is the ratio of the Emissions (in thousand metric tons of CO2 equivalent) of 2008 in Lithuania to that in Luxembourg?
Make the answer very short. 6.98. What is the difference between the highest and the second highest Emissions (in thousand metric tons of CO2 equivalent) in 1990?
Provide a short and direct response. 19.3. What is the difference between the highest and the second highest Emissions (in thousand metric tons of CO2 equivalent) in 2000?
Make the answer very short. 302.5. What is the difference between the highest and the second highest Emissions (in thousand metric tons of CO2 equivalent) in 2005?
Give a very brief answer. 43.5. What is the difference between the highest and the lowest Emissions (in thousand metric tons of CO2 equivalent) in 1990?
Your answer should be very brief. 282.2. What is the difference between the highest and the lowest Emissions (in thousand metric tons of CO2 equivalent) of 2000?
Keep it short and to the point. 446.1. What is the difference between the highest and the lowest Emissions (in thousand metric tons of CO2 equivalent) of 2005?
Offer a very short reply. 825. What is the difference between the highest and the lowest Emissions (in thousand metric tons of CO2 equivalent) in 2008?
Your answer should be compact. 1106.2. 